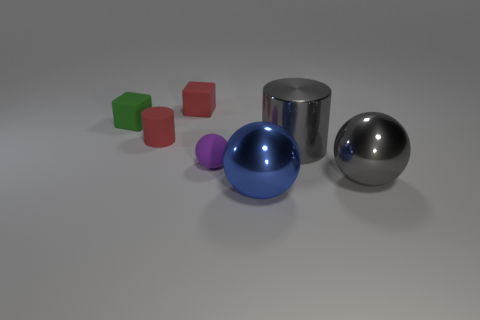Subtract all big spheres. How many spheres are left? 1 Add 2 small red cubes. How many objects exist? 9 Subtract all blocks. How many objects are left? 5 Subtract all purple things. Subtract all large cyan shiny cylinders. How many objects are left? 6 Add 1 tiny purple things. How many tiny purple things are left? 2 Add 5 tiny green things. How many tiny green things exist? 6 Subtract 0 brown blocks. How many objects are left? 7 